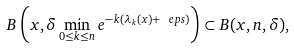Convert formula to latex. <formula><loc_0><loc_0><loc_500><loc_500>B \left ( x , \delta \min _ { 0 \leq k \leq n } e ^ { - k ( \lambda _ { k } ( x ) + \ e p s ) } \right ) \subset B ( x , n , \delta ) ,</formula> 